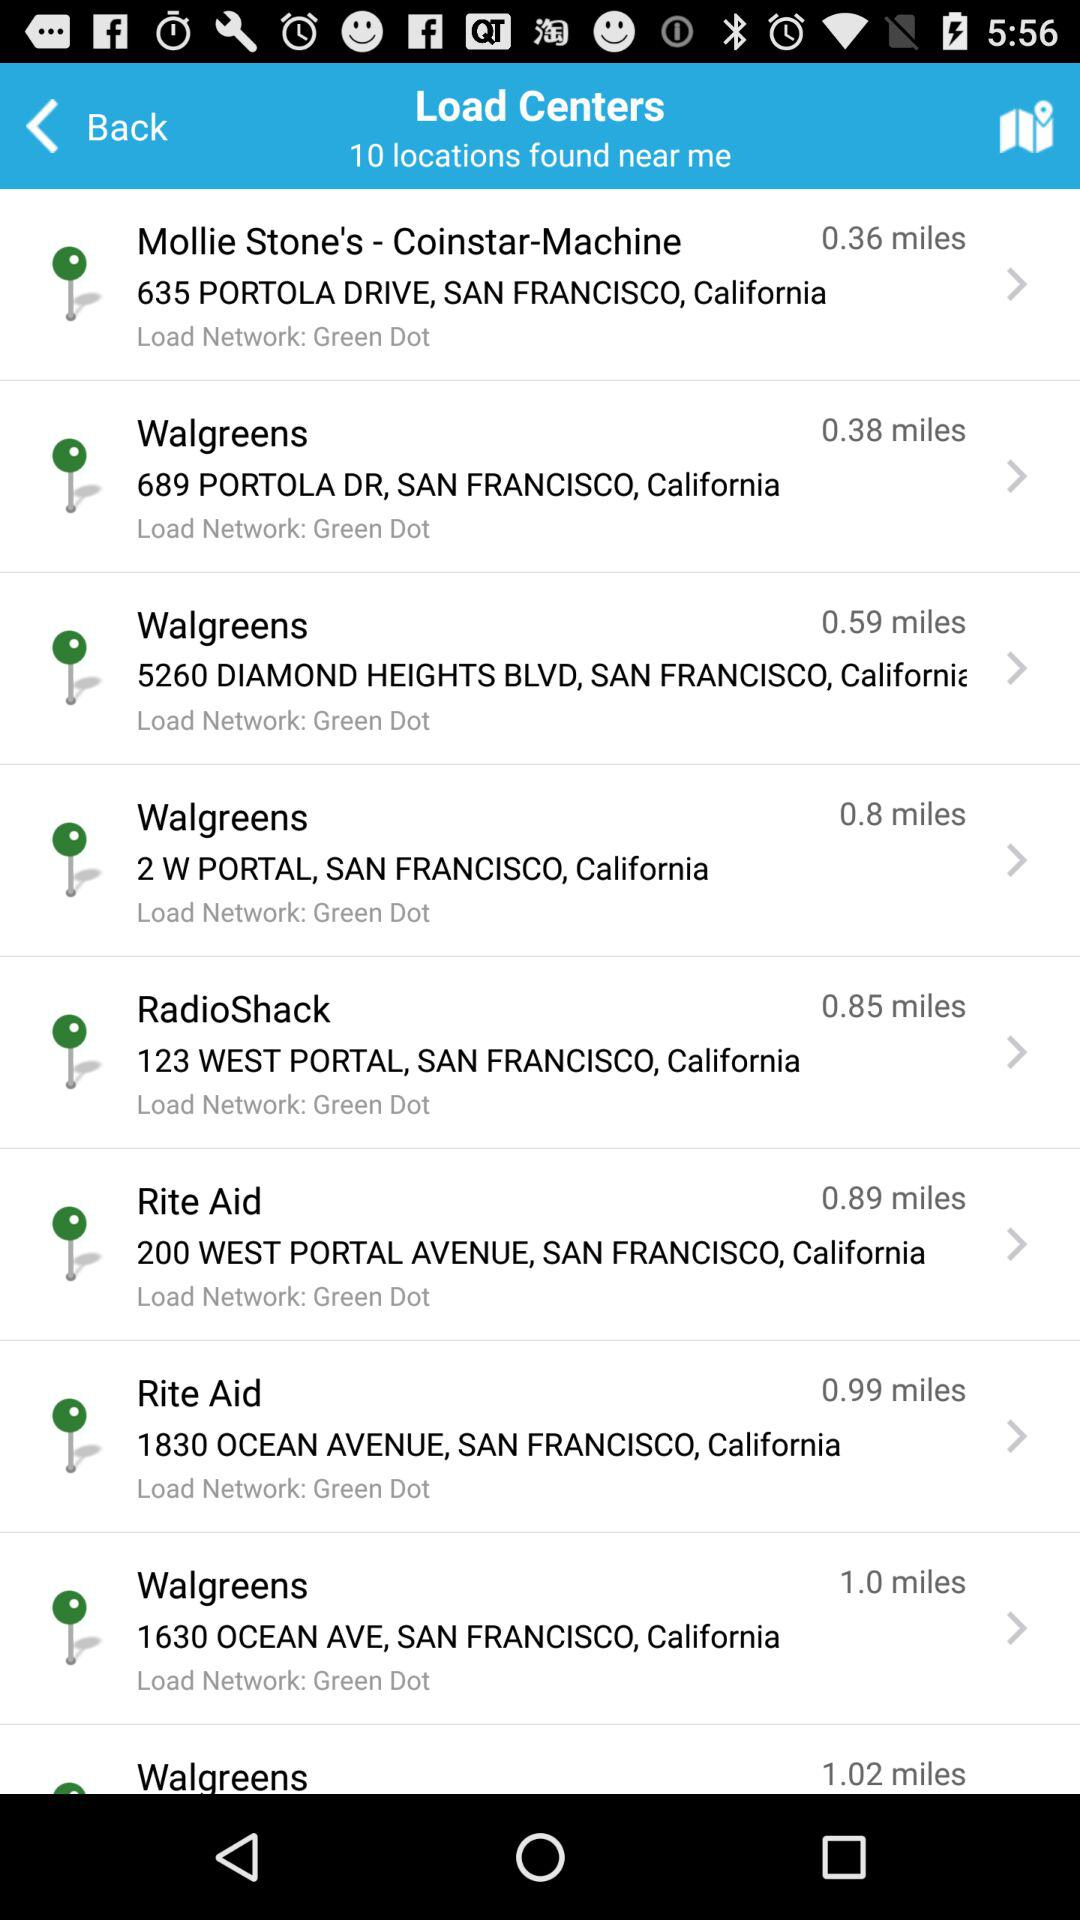How many miles away is "Walgreens" at 689 Portola Dr., San Francisco, California? It is 0.38 miles away. 